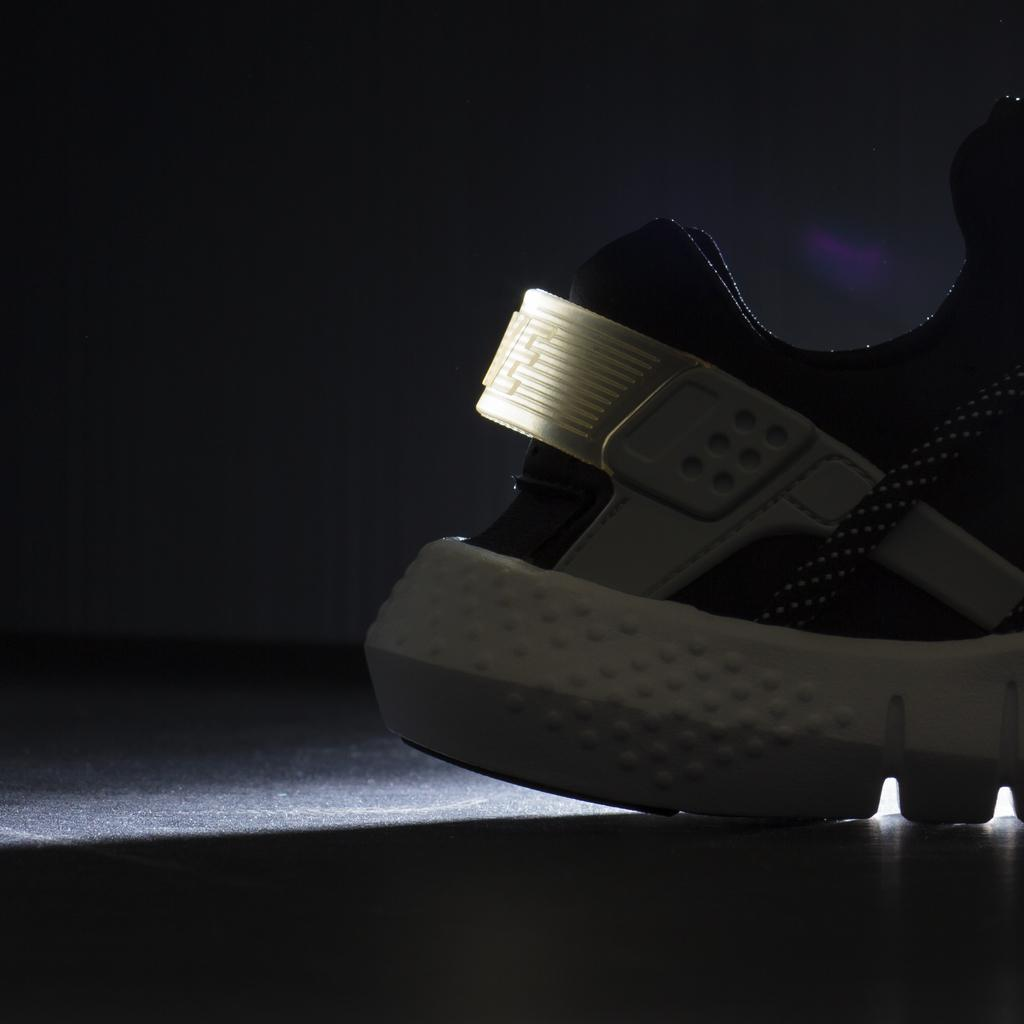What object is on the floor in the image? There is a shoe on the floor in the image. What type of snow can be seen falling on the page in the image? There is no snow, page, or any reference to falling snow in the image; it only features a shoe on the floor. 